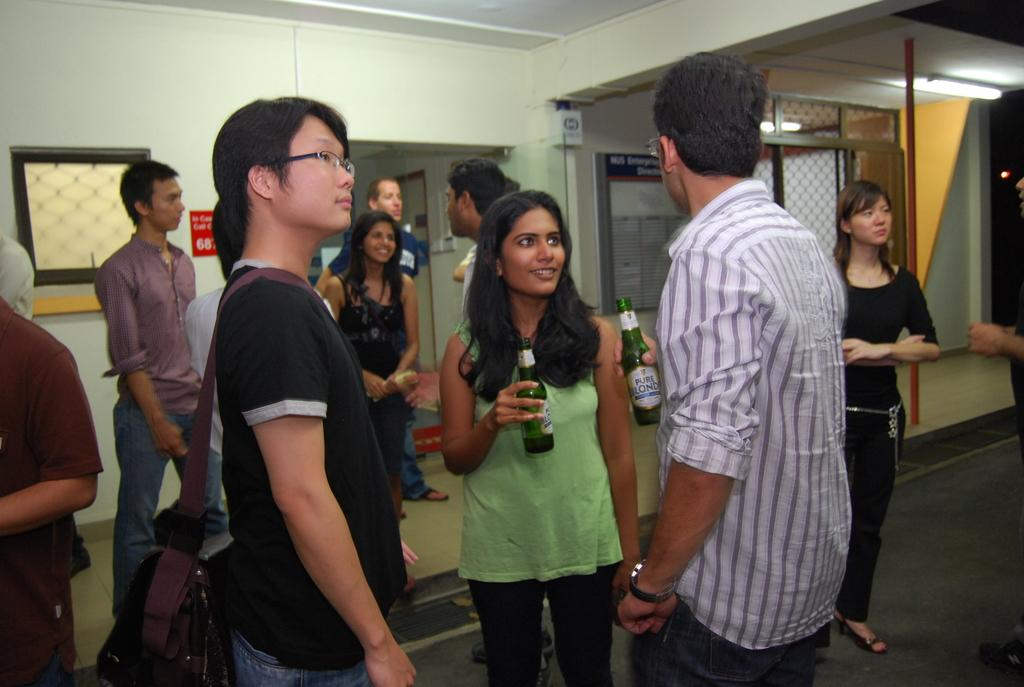How many people are in the image? There is a group of people in the image. What are the people wearing? The people are wearing clothes. What is behind the people in the image? The people are standing in front of a wall. What are two of the people holding in their hands? Two persons are holding bottles with their hands. How many cans are stacked on the shelf in the image? There is no shelf or cans present in the image. 